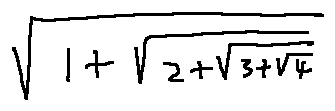Convert formula to latex. <formula><loc_0><loc_0><loc_500><loc_500>\sqrt { 1 + \sqrt { 2 + \sqrt { 3 + \sqrt { 4 } } } }</formula> 